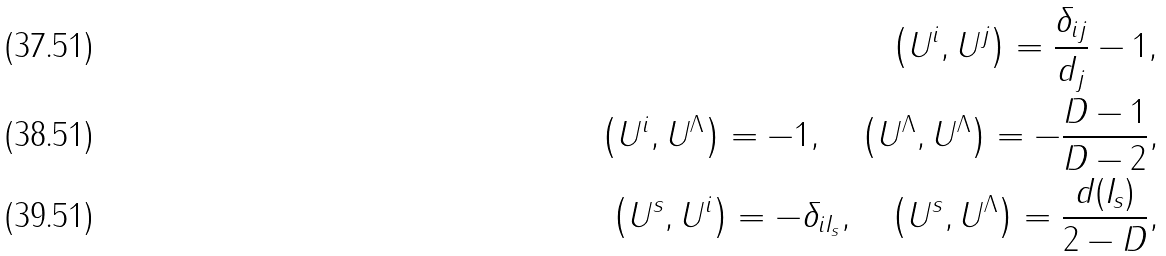Convert formula to latex. <formula><loc_0><loc_0><loc_500><loc_500>\left ( U ^ { i } , U ^ { j } \right ) = \frac { \delta _ { i j } } { d _ { j } } - 1 , \\ \left ( U ^ { i } , U ^ { \Lambda } \right ) = - 1 , \quad \left ( U ^ { \Lambda } , U ^ { \Lambda } \right ) = - \frac { D - 1 } { D - 2 } , \\ \left ( U ^ { s } , U ^ { i } \right ) = - \delta _ { i I _ { s } } , \quad \left ( U ^ { s } , U ^ { \Lambda } \right ) = \frac { d ( I _ { s } ) } { 2 - D } ,</formula> 